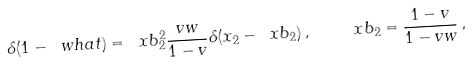Convert formula to latex. <formula><loc_0><loc_0><loc_500><loc_500>\delta ( 1 - \ w h a t ) = \ x b _ { 2 } ^ { 2 } \frac { v w } { 1 - v } \delta ( x _ { 2 } - \ x b _ { 2 } ) \, , \quad \ x b _ { 2 } = \frac { 1 - v } { 1 - v w } \, ,</formula> 